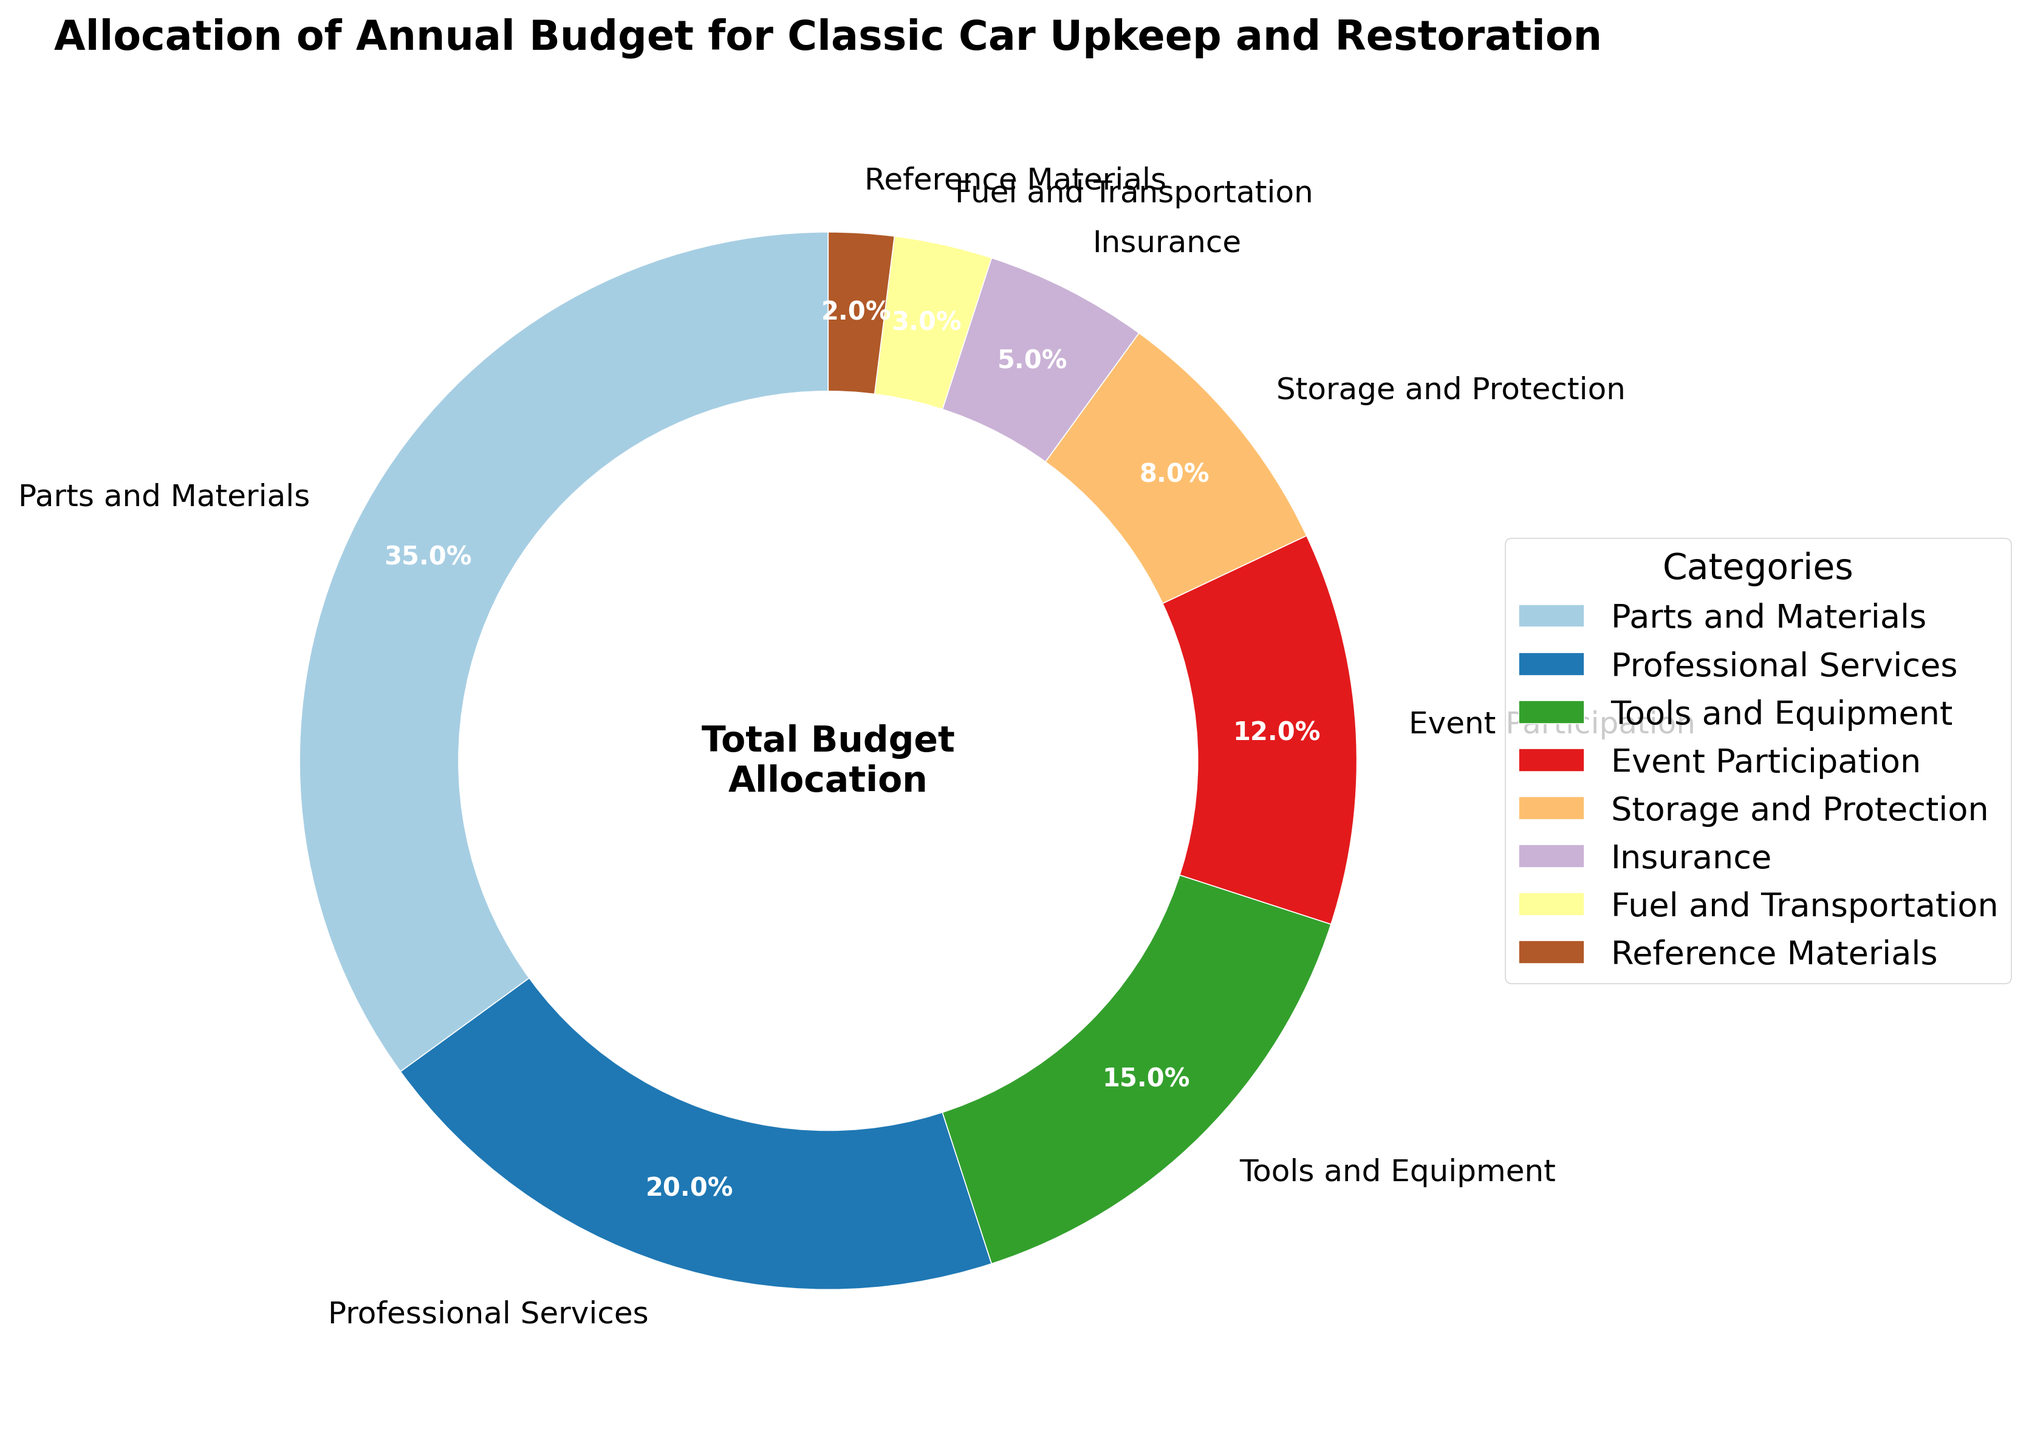Which category has the largest allocation? The pie chart shows various categories with their respective percentages. The largest percentage slice represents "Parts and Materials" with 35%.
Answer: Parts and Materials What is the combined percentage allocation for Tools and Equipment and Event Participation? Adding the percentages for "Tools and Equipment" and "Event Participation", we get 15% + 12% = 27%.
Answer: 27% How much more is allocated to Professional Services compared to Storage and Protection? Subtracting the percentage for "Storage and Protection" from "Professional Services": 20% - 8% = 12%.
Answer: 12% Which categories have an allocation of less than 10%? Checking the slices with percentages less than 10%, we see "Storage and Protection" (8%), "Insurance" (5%), "Fuel and Transportation" (3%), and "Reference Materials" (2%).
Answer: Storage and Protection, Insurance, Fuel and Transportation, Reference Materials What is the total percentage allocation for all the categories combined? Summing up all the percentages: 35% + 20% + 15% + 12% + 8% + 5% + 3% + 2% = 100%.
Answer: 100% Which category uses three times the percentage of Insurance? Insurance is 5%. The category that uses three times this percentage is "Tools and Equipment" with 15% (3 * 5% = 15%).
Answer: Tools and Equipment Is the allocation for Event Participation greater than the allocation for Insurance and Fuel and Transportation combined? Summing the percentages for "Insurance" and "Fuel and Transportation" gives 5% + 3% = 8%. The allocation for "Event Participation" is 12%, which is greater than this sum.
Answer: Yes What percentage is allocated to categories related to physical maintenance (Parts and Materials, Professional Services, Tools and Equipment)? Summing the percentages for "Parts and Materials", "Professional Services", and "Tools and Equipment": 35% + 20% + 15% = 70%.
Answer: 70% Rank the top three categories in terms of budget allocation. Listing the categories from largest to smallest percentage, we get: 1) Parts and Materials (35%), 2) Professional Services (20%), 3) Tools and Equipment (15%).
Answer: Parts and Materials, Professional Services, Tools and Equipment 